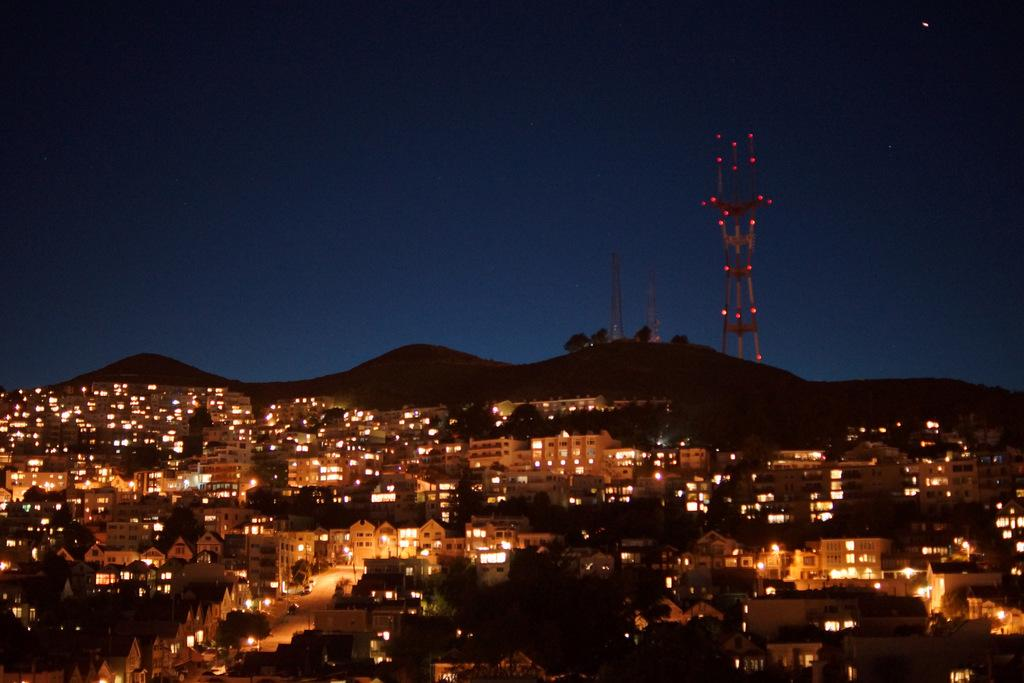What geographical feature is located in the center of the image? There are hills in the center of the image. What type of structures can be seen at the bottom of the image? There are many buildings at the bottom of the image. What can be seen illuminating the scene in the image? Lights are visible in the image. What type of tall structures are present in the background of the image? There are towers in the background of the image. What part of the natural environment is visible in the background of the image? The sky is visible in the background of the image. Can you tell me how many donkeys are pulling a train in the image? There are no donkeys or trains present in the image. What type of creature is carrying luggage in the image? There is no creature carrying luggage in the image. 